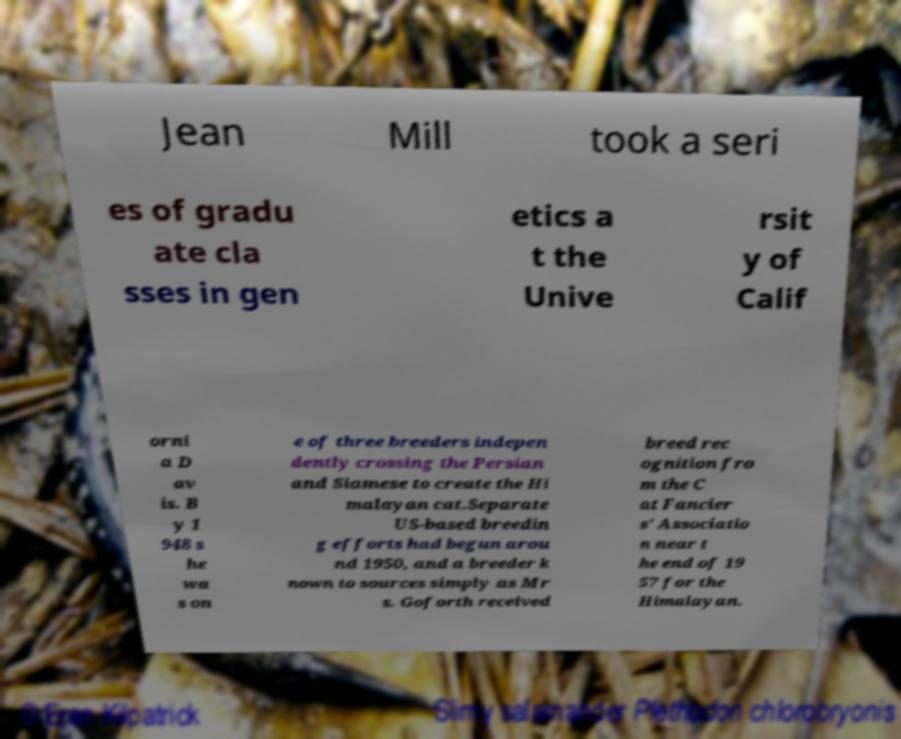For documentation purposes, I need the text within this image transcribed. Could you provide that? Jean Mill took a seri es of gradu ate cla sses in gen etics a t the Unive rsit y of Calif orni a D av is. B y 1 948 s he wa s on e of three breeders indepen dently crossing the Persian and Siamese to create the Hi malayan cat.Separate US-based breedin g efforts had begun arou nd 1950, and a breeder k nown to sources simply as Mr s. Goforth received breed rec ognition fro m the C at Fancier s' Associatio n near t he end of 19 57 for the Himalayan. 